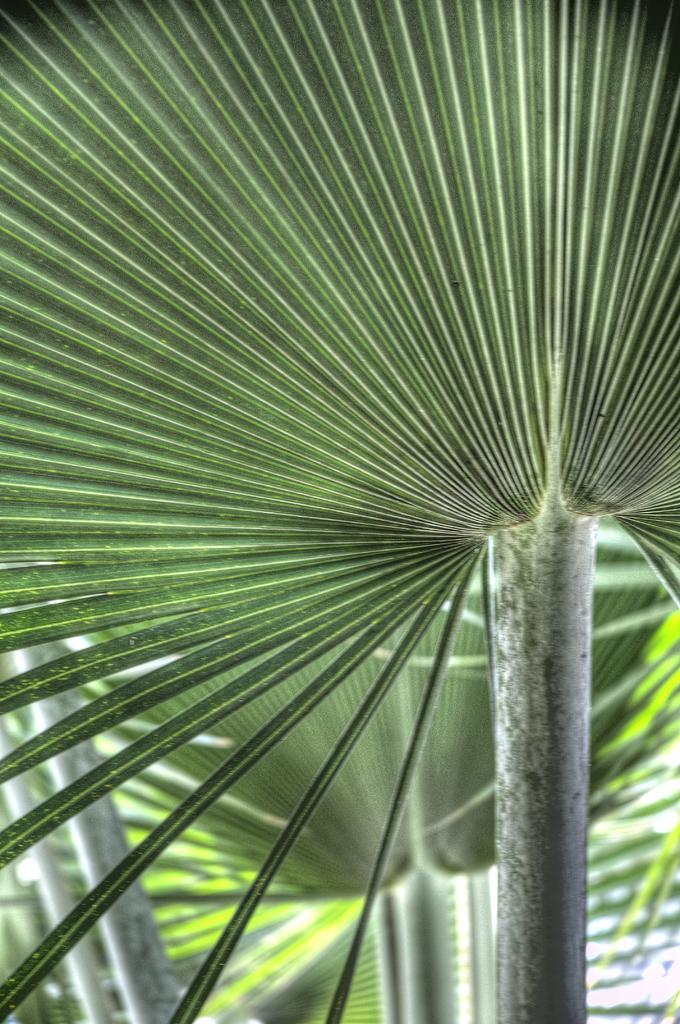What type of vegetation is present in the image? There are leaves in the image. What type of iron can be seen in the image? There is no iron present in the image; it only contains leaves. 